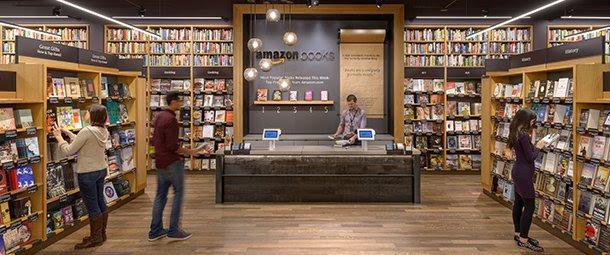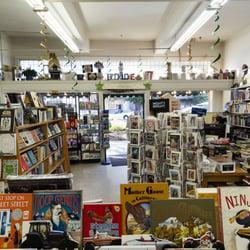The first image is the image on the left, the second image is the image on the right. For the images shown, is this caption "One image shows a seating area in a book store." true? Answer yes or no. No. The first image is the image on the left, the second image is the image on the right. For the images displayed, is the sentence "There is at least one person in the image on the left." factually correct? Answer yes or no. Yes. 